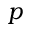Convert formula to latex. <formula><loc_0><loc_0><loc_500><loc_500>p</formula> 